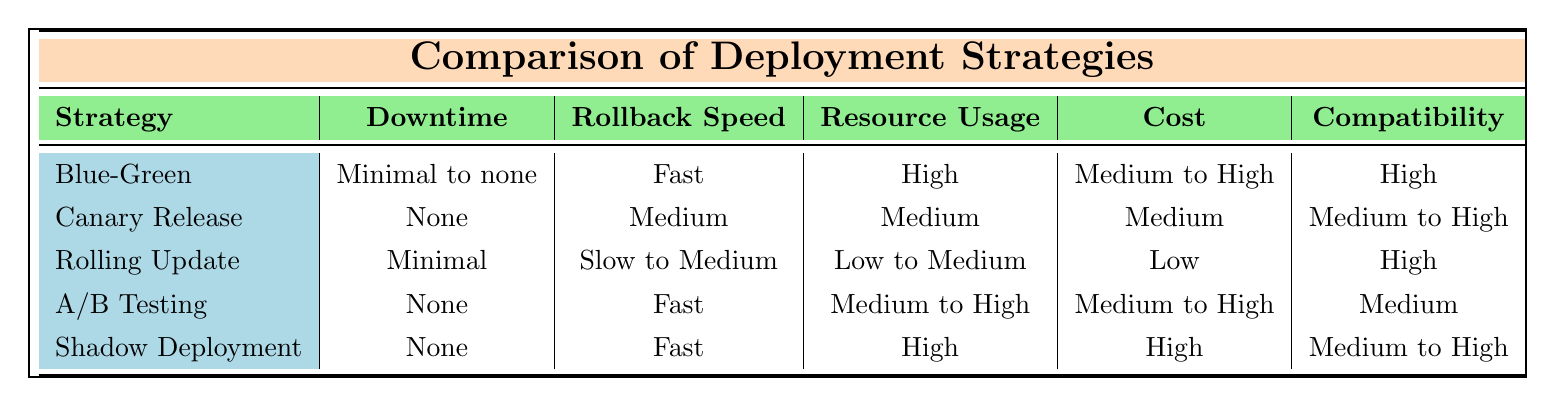What is the downtime for the Canary Release strategy? According to the table, the downtime for the Canary Release strategy is "None."
Answer: None Which deployment strategy has the fastest rollback speed? The table indicates that both Blue-Green Deployment and Shadow Deployment have a rollback speed categorized as "Fast."
Answer: Blue-Green Deployment and Shadow Deployment What is the resource usage level for Rolling Update? The table specifies that the resource usage for Rolling Update is "Low to Medium."
Answer: Low to Medium How does the cost of Rolling Update compare to A/B Testing? Rolling Update has a cost labeled as "Low," while A/B Testing is categorized as "Medium to High." Therefore, Rolling Update is less expensive than A/B Testing.
Answer: Less expensive Is the compatibility with accounting software the same for Blue-Green Deployment and Rolling Update? The compatibility for Blue-Green Deployment is "High," and for Rolling Update, it is also "High." Therefore, both strategies have the same level of compatibility.
Answer: Yes Which strategy has the highest user experience impact and what is that level? The table shows that Rolling Update has a user experience impact labeled as "Medium," which is the highest impact level among the listed strategies.
Answer: Medium What is the average downtime across the listed strategies? The downtimes listed are: "Minimal to none" (considered as 0), "None" (0), "Minimal" (considered as 0), "None" (0), and "None" (0). Thus, the average is (0 + 0 + 0 + 0 + 0) / 5 = 0 minutes.
Answer: 0 minutes Does the A/B Testing strategy have a higher error rate during deployment than the Shadow Deployment strategy? A/B Testing has an error rate of "< 0.3%", while Shadow Deployment has "< 0.2%." Since 0.3% is greater than 0.2%, A/B Testing does have a higher error rate.
Answer: Yes Which deployment strategy allows for the least resource usage? The table indicates that Rolling Update has "Low to Medium" resource usage, which is the least comparative to others like Blue-Green and Shadow which are "High" or "Medium to High."
Answer: Rolling Update 